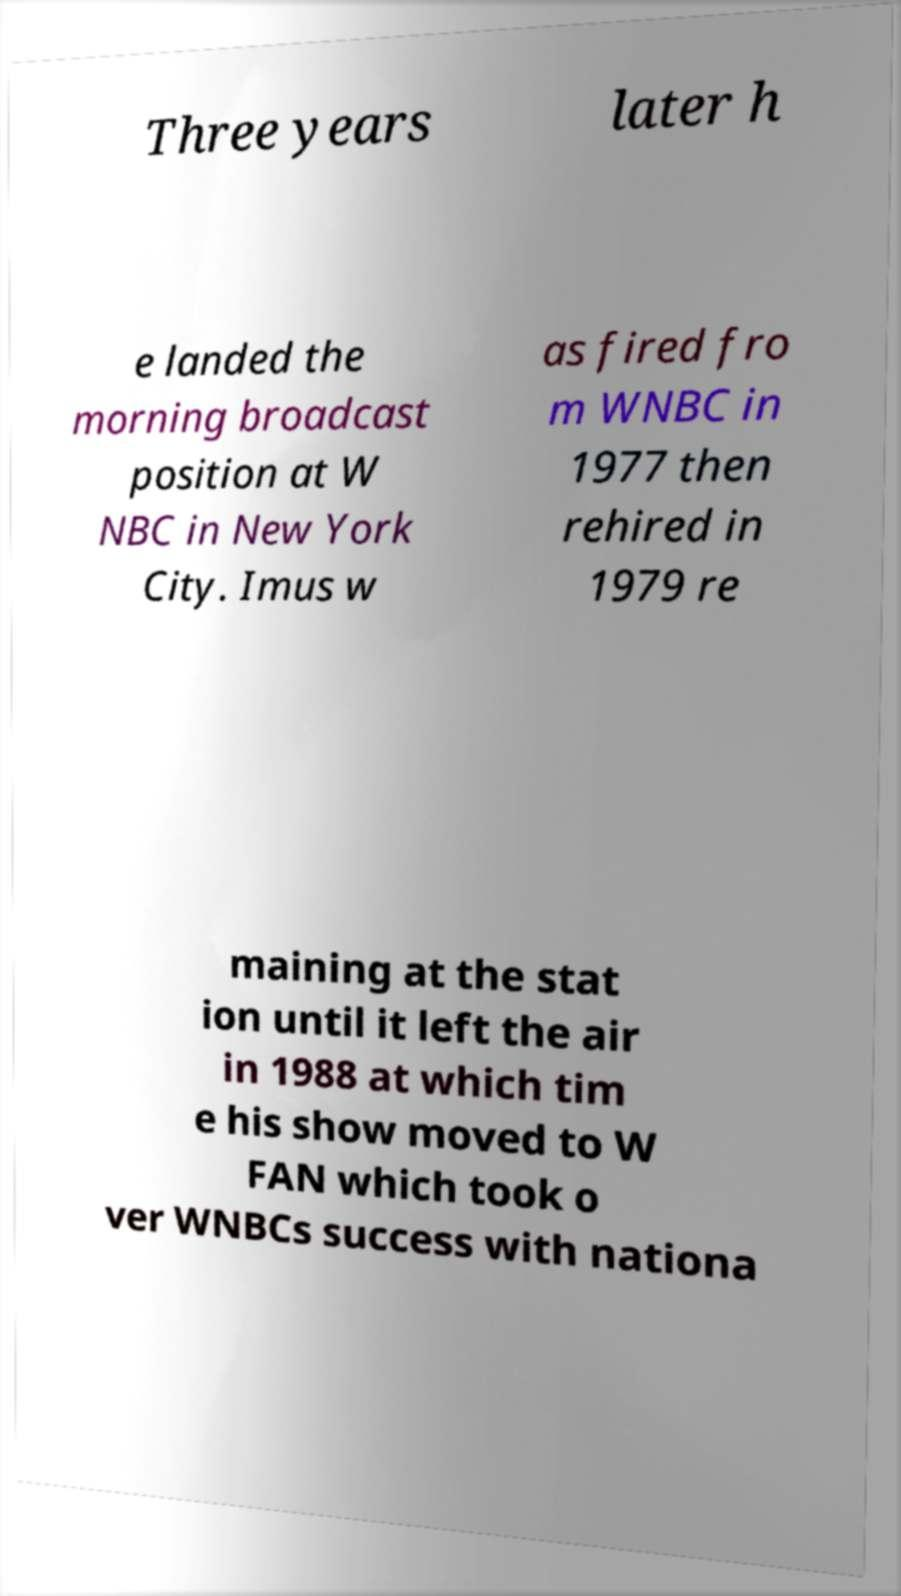Can you read and provide the text displayed in the image?This photo seems to have some interesting text. Can you extract and type it out for me? Three years later h e landed the morning broadcast position at W NBC in New York City. Imus w as fired fro m WNBC in 1977 then rehired in 1979 re maining at the stat ion until it left the air in 1988 at which tim e his show moved to W FAN which took o ver WNBCs success with nationa 